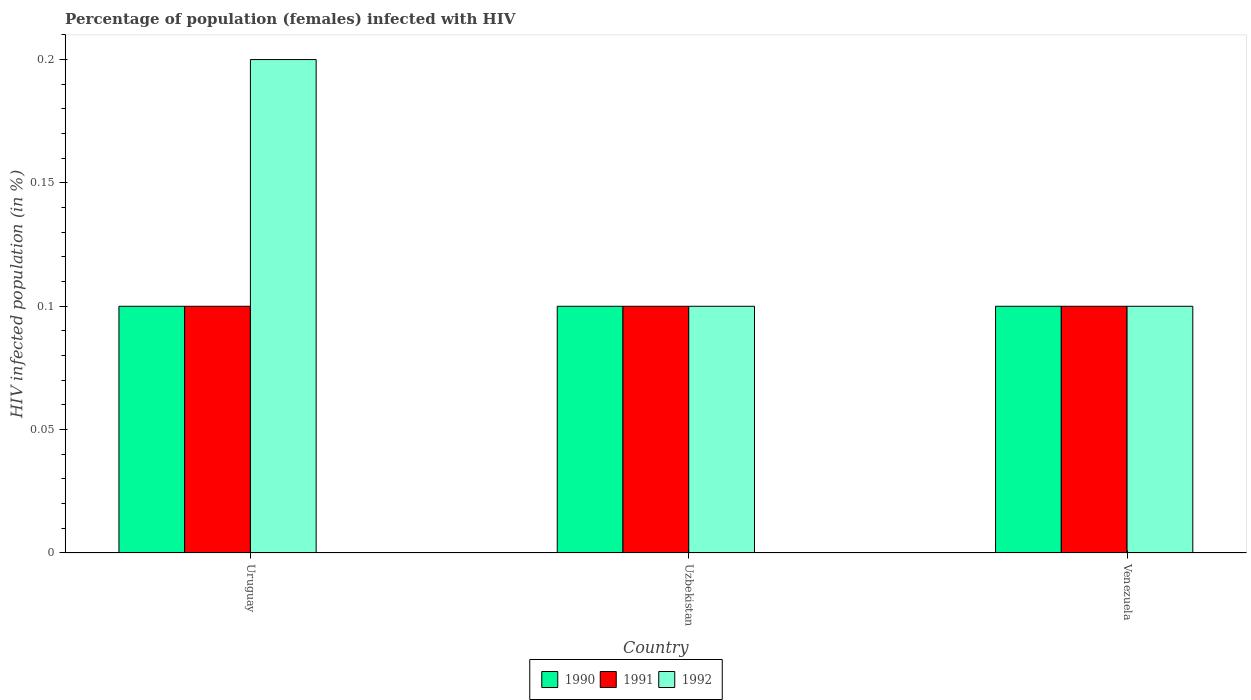How many groups of bars are there?
Offer a terse response. 3. Are the number of bars per tick equal to the number of legend labels?
Your response must be concise. Yes. Are the number of bars on each tick of the X-axis equal?
Offer a terse response. Yes. How many bars are there on the 3rd tick from the right?
Your answer should be compact. 3. What is the label of the 1st group of bars from the left?
Ensure brevity in your answer.  Uruguay. In how many cases, is the number of bars for a given country not equal to the number of legend labels?
Your response must be concise. 0. What is the percentage of HIV infected female population in 1990 in Uruguay?
Ensure brevity in your answer.  0.1. Across all countries, what is the minimum percentage of HIV infected female population in 1990?
Make the answer very short. 0.1. In which country was the percentage of HIV infected female population in 1990 maximum?
Your answer should be very brief. Uruguay. In which country was the percentage of HIV infected female population in 1991 minimum?
Your response must be concise. Uruguay. What is the difference between the percentage of HIV infected female population in 1990 in Uzbekistan and that in Venezuela?
Your response must be concise. 0. What is the difference between the percentage of HIV infected female population in 1991 in Uruguay and the percentage of HIV infected female population in 1992 in Uzbekistan?
Provide a succinct answer. 0. What is the average percentage of HIV infected female population in 1991 per country?
Provide a short and direct response. 0.1. What is the difference between the percentage of HIV infected female population of/in 1990 and percentage of HIV infected female population of/in 1991 in Uruguay?
Your answer should be very brief. 0. What is the ratio of the percentage of HIV infected female population in 1990 in Uruguay to that in Venezuela?
Provide a succinct answer. 1. What is the difference between the highest and the second highest percentage of HIV infected female population in 1992?
Make the answer very short. 0.1. What is the difference between the highest and the lowest percentage of HIV infected female population in 1990?
Offer a very short reply. 0. How many bars are there?
Ensure brevity in your answer.  9. What is the difference between two consecutive major ticks on the Y-axis?
Provide a succinct answer. 0.05. Are the values on the major ticks of Y-axis written in scientific E-notation?
Make the answer very short. No. Does the graph contain any zero values?
Offer a very short reply. No. How many legend labels are there?
Offer a terse response. 3. What is the title of the graph?
Your answer should be very brief. Percentage of population (females) infected with HIV. What is the label or title of the Y-axis?
Offer a terse response. HIV infected population (in %). What is the HIV infected population (in %) of 1990 in Uruguay?
Provide a short and direct response. 0.1. What is the HIV infected population (in %) of 1991 in Uruguay?
Ensure brevity in your answer.  0.1. What is the HIV infected population (in %) of 1992 in Uruguay?
Offer a terse response. 0.2. What is the HIV infected population (in %) of 1992 in Uzbekistan?
Offer a very short reply. 0.1. Across all countries, what is the maximum HIV infected population (in %) of 1990?
Make the answer very short. 0.1. Across all countries, what is the maximum HIV infected population (in %) of 1992?
Offer a terse response. 0.2. Across all countries, what is the minimum HIV infected population (in %) of 1990?
Ensure brevity in your answer.  0.1. What is the total HIV infected population (in %) of 1992 in the graph?
Provide a succinct answer. 0.4. What is the difference between the HIV infected population (in %) of 1990 in Uruguay and that in Uzbekistan?
Ensure brevity in your answer.  0. What is the difference between the HIV infected population (in %) of 1991 in Uruguay and that in Uzbekistan?
Your answer should be very brief. 0. What is the difference between the HIV infected population (in %) in 1992 in Uruguay and that in Uzbekistan?
Your answer should be very brief. 0.1. What is the difference between the HIV infected population (in %) in 1990 in Uruguay and that in Venezuela?
Give a very brief answer. 0. What is the difference between the HIV infected population (in %) of 1991 in Uruguay and that in Venezuela?
Your answer should be compact. 0. What is the difference between the HIV infected population (in %) in 1990 in Uzbekistan and that in Venezuela?
Your response must be concise. 0. What is the difference between the HIV infected population (in %) in 1992 in Uzbekistan and that in Venezuela?
Offer a very short reply. 0. What is the difference between the HIV infected population (in %) of 1990 in Uruguay and the HIV infected population (in %) of 1991 in Uzbekistan?
Provide a short and direct response. 0. What is the difference between the HIV infected population (in %) of 1990 in Uruguay and the HIV infected population (in %) of 1991 in Venezuela?
Your answer should be very brief. 0. What is the difference between the HIV infected population (in %) of 1990 in Uruguay and the HIV infected population (in %) of 1992 in Venezuela?
Offer a very short reply. 0. What is the difference between the HIV infected population (in %) in 1991 in Uzbekistan and the HIV infected population (in %) in 1992 in Venezuela?
Provide a succinct answer. 0. What is the average HIV infected population (in %) in 1990 per country?
Provide a succinct answer. 0.1. What is the average HIV infected population (in %) in 1991 per country?
Offer a terse response. 0.1. What is the average HIV infected population (in %) of 1992 per country?
Offer a very short reply. 0.13. What is the difference between the HIV infected population (in %) of 1990 and HIV infected population (in %) of 1991 in Uruguay?
Give a very brief answer. 0. What is the difference between the HIV infected population (in %) of 1990 and HIV infected population (in %) of 1992 in Uzbekistan?
Your response must be concise. 0. What is the difference between the HIV infected population (in %) in 1991 and HIV infected population (in %) in 1992 in Uzbekistan?
Offer a very short reply. 0. What is the difference between the HIV infected population (in %) of 1990 and HIV infected population (in %) of 1991 in Venezuela?
Provide a succinct answer. 0. What is the ratio of the HIV infected population (in %) in 1991 in Uruguay to that in Uzbekistan?
Provide a short and direct response. 1. What is the ratio of the HIV infected population (in %) of 1990 in Uruguay to that in Venezuela?
Ensure brevity in your answer.  1. What is the ratio of the HIV infected population (in %) of 1992 in Uruguay to that in Venezuela?
Keep it short and to the point. 2. What is the ratio of the HIV infected population (in %) of 1990 in Uzbekistan to that in Venezuela?
Give a very brief answer. 1. What is the difference between the highest and the second highest HIV infected population (in %) of 1990?
Offer a terse response. 0. What is the difference between the highest and the second highest HIV infected population (in %) in 1992?
Your response must be concise. 0.1. What is the difference between the highest and the lowest HIV infected population (in %) of 1992?
Offer a terse response. 0.1. 